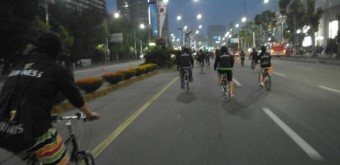How many bicycles are there in the image? There are three bicycles being ridden by people in the image, which captures a serene evening ride through an urban street lined with trees and illuminated by streetlights. 